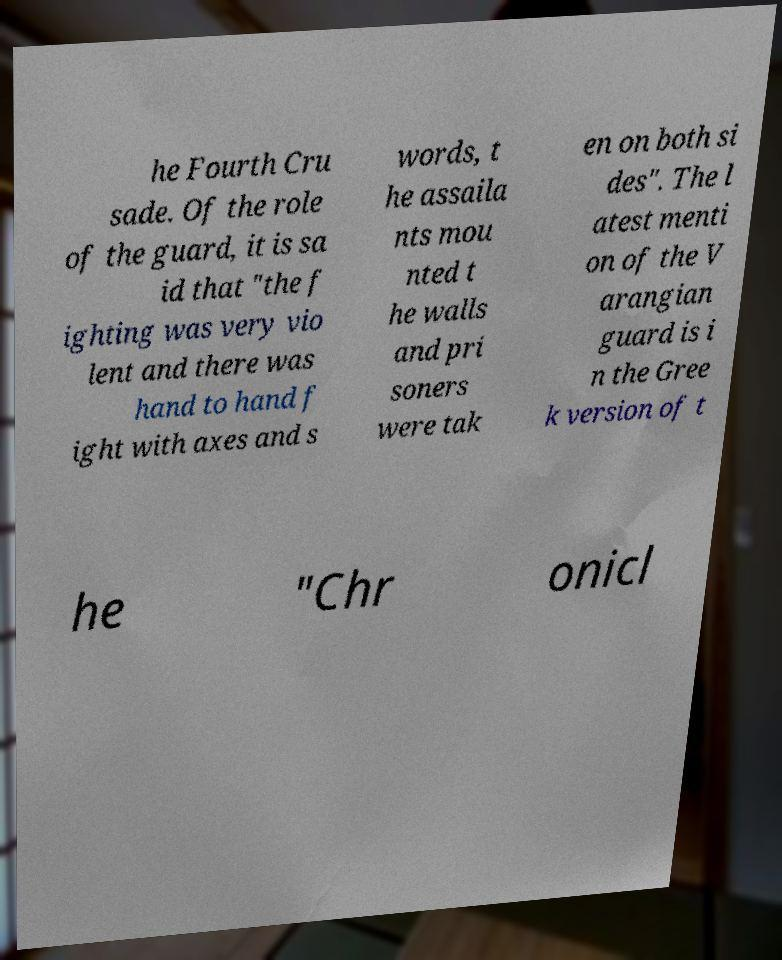Please identify and transcribe the text found in this image. he Fourth Cru sade. Of the role of the guard, it is sa id that "the f ighting was very vio lent and there was hand to hand f ight with axes and s words, t he assaila nts mou nted t he walls and pri soners were tak en on both si des". The l atest menti on of the V arangian guard is i n the Gree k version of t he "Chr onicl 